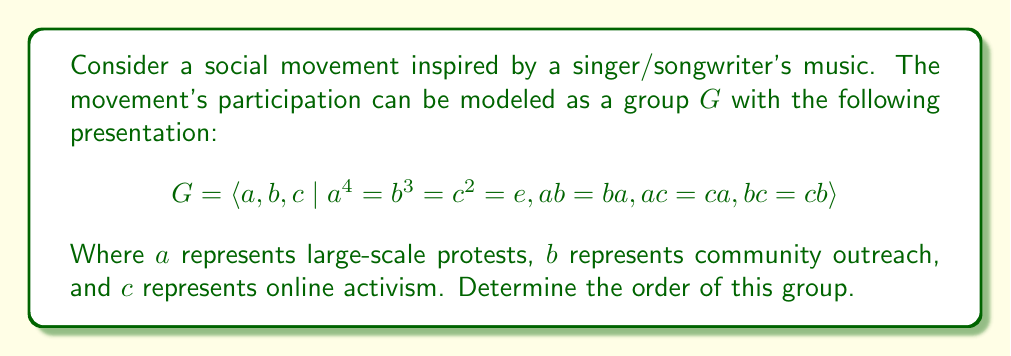Could you help me with this problem? To determine the order of the group $G$, we'll follow these steps:

1) First, note that this is an abelian group since all generators commute with each other (given by $ab = ba$, $ac = ca$, and $bc = cb$).

2) The group is generated by three elements $a$, $b$, and $c$, with orders 4, 3, and 2 respectively.

3) For abelian groups, we can use the fact that the order of the group is the product of the orders of its generators if these orders are coprime (relatively prime).

4) Let's check if 4, 3, and 2 are coprime:
   - $gcd(4,3) = 1$
   - $gcd(4,2) = 2$
   - $gcd(3,2) = 1$

5) Since not all pairs are coprime, we can't simply multiply the orders. Instead, we need to find the least common multiple (LCM) of these orders.

6) $LCM(4,3,2) = LCM(LCM(4,3),2)$

7) $LCM(4,3) = 12$ (since $4 \times 3 = 12$)

8) $LCM(12,2) = 12$ (since 12 is already divisible by 2)

Therefore, the order of the group $G$ is 12.

This means there are 12 unique combinations of protest actions (large-scale protests, community outreach, and online activism) in this social movement model.
Answer: The order of the group $G$ is 12. 